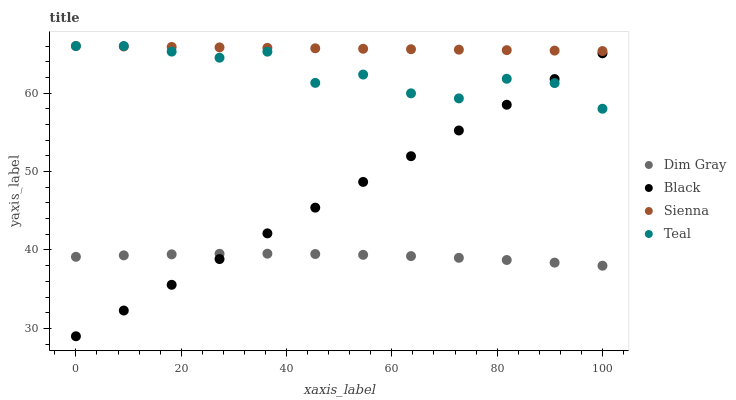Does Dim Gray have the minimum area under the curve?
Answer yes or no. Yes. Does Sienna have the maximum area under the curve?
Answer yes or no. Yes. Does Black have the minimum area under the curve?
Answer yes or no. No. Does Black have the maximum area under the curve?
Answer yes or no. No. Is Black the smoothest?
Answer yes or no. Yes. Is Teal the roughest?
Answer yes or no. Yes. Is Dim Gray the smoothest?
Answer yes or no. No. Is Dim Gray the roughest?
Answer yes or no. No. Does Black have the lowest value?
Answer yes or no. Yes. Does Dim Gray have the lowest value?
Answer yes or no. No. Does Teal have the highest value?
Answer yes or no. Yes. Does Black have the highest value?
Answer yes or no. No. Is Dim Gray less than Sienna?
Answer yes or no. Yes. Is Sienna greater than Black?
Answer yes or no. Yes. Does Teal intersect Sienna?
Answer yes or no. Yes. Is Teal less than Sienna?
Answer yes or no. No. Is Teal greater than Sienna?
Answer yes or no. No. Does Dim Gray intersect Sienna?
Answer yes or no. No. 